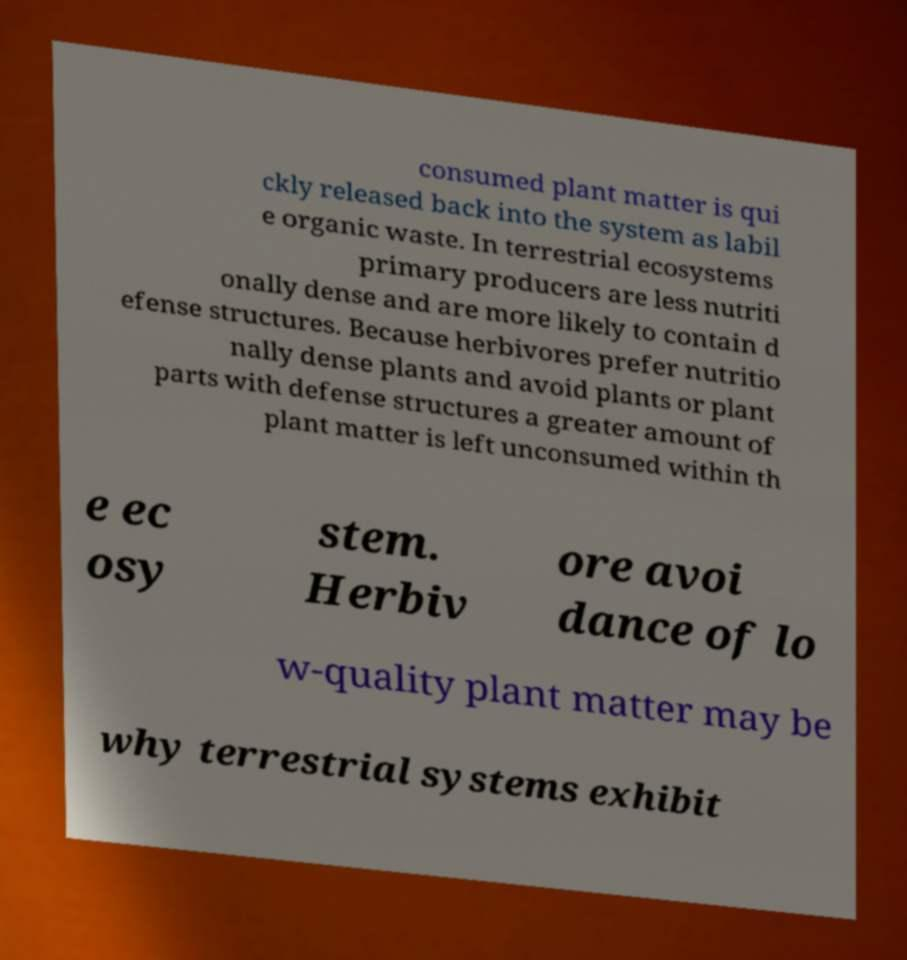Can you accurately transcribe the text from the provided image for me? consumed plant matter is qui ckly released back into the system as labil e organic waste. In terrestrial ecosystems primary producers are less nutriti onally dense and are more likely to contain d efense structures. Because herbivores prefer nutritio nally dense plants and avoid plants or plant parts with defense structures a greater amount of plant matter is left unconsumed within th e ec osy stem. Herbiv ore avoi dance of lo w-quality plant matter may be why terrestrial systems exhibit 